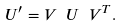<formula> <loc_0><loc_0><loc_500><loc_500>U ^ { \prime } = V \ U \ V ^ { T } .</formula> 